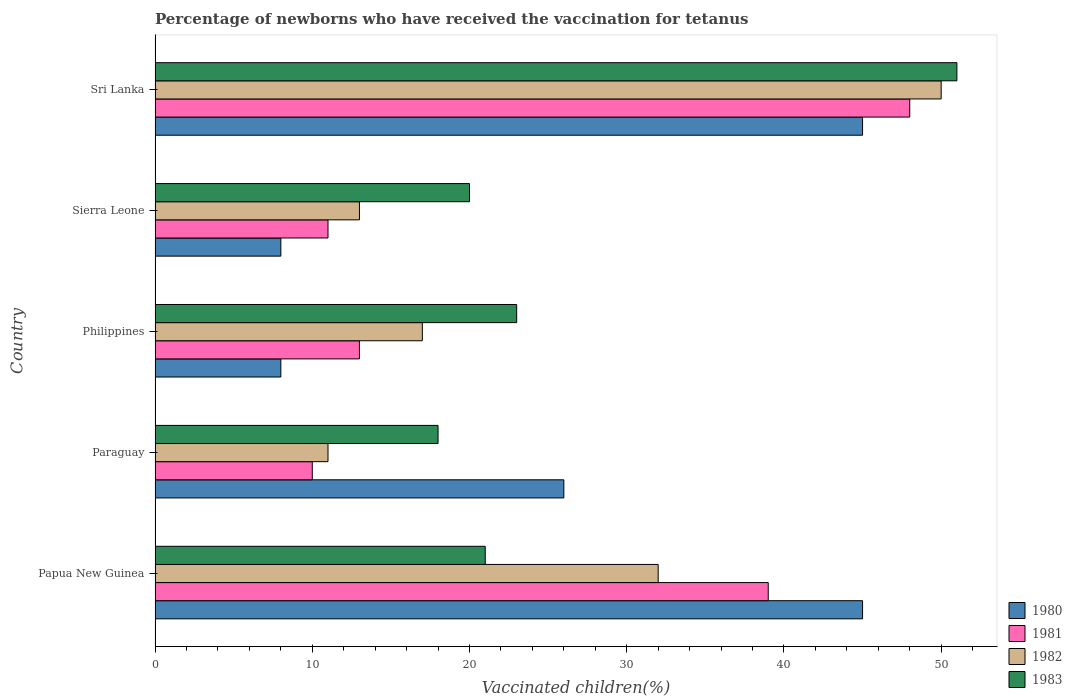Are the number of bars per tick equal to the number of legend labels?
Your answer should be compact. Yes. What is the label of the 4th group of bars from the top?
Provide a succinct answer. Paraguay. What is the percentage of vaccinated children in 1983 in Papua New Guinea?
Offer a terse response. 21. Across all countries, what is the maximum percentage of vaccinated children in 1981?
Offer a terse response. 48. Across all countries, what is the minimum percentage of vaccinated children in 1980?
Your answer should be compact. 8. In which country was the percentage of vaccinated children in 1981 maximum?
Offer a terse response. Sri Lanka. In which country was the percentage of vaccinated children in 1981 minimum?
Your answer should be compact. Paraguay. What is the total percentage of vaccinated children in 1981 in the graph?
Your answer should be very brief. 121. What is the difference between the percentage of vaccinated children in 1982 in Sierra Leone and that in Sri Lanka?
Make the answer very short. -37. What is the difference between the percentage of vaccinated children in 1981 in Papua New Guinea and the percentage of vaccinated children in 1980 in Sri Lanka?
Offer a very short reply. -6. What is the average percentage of vaccinated children in 1980 per country?
Offer a terse response. 26.4. What is the ratio of the percentage of vaccinated children in 1983 in Paraguay to that in Sri Lanka?
Your answer should be compact. 0.35. Is the difference between the percentage of vaccinated children in 1983 in Paraguay and Sri Lanka greater than the difference between the percentage of vaccinated children in 1980 in Paraguay and Sri Lanka?
Keep it short and to the point. No. In how many countries, is the percentage of vaccinated children in 1981 greater than the average percentage of vaccinated children in 1981 taken over all countries?
Your response must be concise. 2. Is the sum of the percentage of vaccinated children in 1980 in Philippines and Sri Lanka greater than the maximum percentage of vaccinated children in 1983 across all countries?
Keep it short and to the point. Yes. Is it the case that in every country, the sum of the percentage of vaccinated children in 1983 and percentage of vaccinated children in 1981 is greater than the percentage of vaccinated children in 1980?
Provide a succinct answer. Yes. How many bars are there?
Give a very brief answer. 20. What is the difference between two consecutive major ticks on the X-axis?
Your answer should be compact. 10. Are the values on the major ticks of X-axis written in scientific E-notation?
Provide a succinct answer. No. Does the graph contain any zero values?
Your answer should be compact. No. Does the graph contain grids?
Make the answer very short. No. How many legend labels are there?
Provide a succinct answer. 4. How are the legend labels stacked?
Provide a short and direct response. Vertical. What is the title of the graph?
Your response must be concise. Percentage of newborns who have received the vaccination for tetanus. What is the label or title of the X-axis?
Offer a terse response. Vaccinated children(%). What is the label or title of the Y-axis?
Offer a very short reply. Country. What is the Vaccinated children(%) of 1982 in Papua New Guinea?
Your answer should be very brief. 32. What is the Vaccinated children(%) in 1983 in Papua New Guinea?
Give a very brief answer. 21. What is the Vaccinated children(%) in 1980 in Paraguay?
Offer a terse response. 26. What is the Vaccinated children(%) in 1981 in Paraguay?
Give a very brief answer. 10. What is the Vaccinated children(%) in 1982 in Paraguay?
Offer a very short reply. 11. What is the Vaccinated children(%) in 1983 in Paraguay?
Your answer should be very brief. 18. What is the Vaccinated children(%) in 1980 in Philippines?
Make the answer very short. 8. What is the Vaccinated children(%) in 1981 in Philippines?
Ensure brevity in your answer.  13. What is the Vaccinated children(%) of 1980 in Sierra Leone?
Provide a succinct answer. 8. What is the Vaccinated children(%) in 1981 in Sierra Leone?
Your response must be concise. 11. What is the Vaccinated children(%) of 1982 in Sierra Leone?
Give a very brief answer. 13. Across all countries, what is the maximum Vaccinated children(%) in 1980?
Your response must be concise. 45. Across all countries, what is the maximum Vaccinated children(%) of 1981?
Offer a very short reply. 48. Across all countries, what is the maximum Vaccinated children(%) in 1982?
Give a very brief answer. 50. Across all countries, what is the maximum Vaccinated children(%) of 1983?
Offer a very short reply. 51. Across all countries, what is the minimum Vaccinated children(%) in 1980?
Your answer should be very brief. 8. What is the total Vaccinated children(%) of 1980 in the graph?
Provide a short and direct response. 132. What is the total Vaccinated children(%) of 1981 in the graph?
Provide a short and direct response. 121. What is the total Vaccinated children(%) of 1982 in the graph?
Ensure brevity in your answer.  123. What is the total Vaccinated children(%) in 1983 in the graph?
Provide a short and direct response. 133. What is the difference between the Vaccinated children(%) of 1981 in Papua New Guinea and that in Paraguay?
Keep it short and to the point. 29. What is the difference between the Vaccinated children(%) in 1982 in Papua New Guinea and that in Paraguay?
Offer a very short reply. 21. What is the difference between the Vaccinated children(%) in 1980 in Papua New Guinea and that in Philippines?
Your answer should be very brief. 37. What is the difference between the Vaccinated children(%) of 1981 in Papua New Guinea and that in Philippines?
Your answer should be very brief. 26. What is the difference between the Vaccinated children(%) in 1983 in Papua New Guinea and that in Philippines?
Keep it short and to the point. -2. What is the difference between the Vaccinated children(%) in 1981 in Papua New Guinea and that in Sierra Leone?
Give a very brief answer. 28. What is the difference between the Vaccinated children(%) of 1983 in Papua New Guinea and that in Sierra Leone?
Provide a short and direct response. 1. What is the difference between the Vaccinated children(%) of 1980 in Papua New Guinea and that in Sri Lanka?
Your response must be concise. 0. What is the difference between the Vaccinated children(%) in 1981 in Papua New Guinea and that in Sri Lanka?
Your answer should be compact. -9. What is the difference between the Vaccinated children(%) of 1982 in Papua New Guinea and that in Sri Lanka?
Your response must be concise. -18. What is the difference between the Vaccinated children(%) in 1983 in Papua New Guinea and that in Sri Lanka?
Offer a terse response. -30. What is the difference between the Vaccinated children(%) of 1981 in Paraguay and that in Philippines?
Give a very brief answer. -3. What is the difference between the Vaccinated children(%) in 1982 in Paraguay and that in Philippines?
Your answer should be very brief. -6. What is the difference between the Vaccinated children(%) in 1983 in Paraguay and that in Philippines?
Offer a terse response. -5. What is the difference between the Vaccinated children(%) in 1980 in Paraguay and that in Sierra Leone?
Give a very brief answer. 18. What is the difference between the Vaccinated children(%) in 1981 in Paraguay and that in Sierra Leone?
Offer a terse response. -1. What is the difference between the Vaccinated children(%) in 1982 in Paraguay and that in Sierra Leone?
Your response must be concise. -2. What is the difference between the Vaccinated children(%) in 1983 in Paraguay and that in Sierra Leone?
Ensure brevity in your answer.  -2. What is the difference between the Vaccinated children(%) of 1981 in Paraguay and that in Sri Lanka?
Provide a short and direct response. -38. What is the difference between the Vaccinated children(%) of 1982 in Paraguay and that in Sri Lanka?
Ensure brevity in your answer.  -39. What is the difference between the Vaccinated children(%) in 1983 in Paraguay and that in Sri Lanka?
Provide a succinct answer. -33. What is the difference between the Vaccinated children(%) in 1980 in Philippines and that in Sierra Leone?
Your response must be concise. 0. What is the difference between the Vaccinated children(%) in 1983 in Philippines and that in Sierra Leone?
Provide a succinct answer. 3. What is the difference between the Vaccinated children(%) in 1980 in Philippines and that in Sri Lanka?
Provide a short and direct response. -37. What is the difference between the Vaccinated children(%) of 1981 in Philippines and that in Sri Lanka?
Your answer should be compact. -35. What is the difference between the Vaccinated children(%) in 1982 in Philippines and that in Sri Lanka?
Make the answer very short. -33. What is the difference between the Vaccinated children(%) in 1980 in Sierra Leone and that in Sri Lanka?
Make the answer very short. -37. What is the difference between the Vaccinated children(%) in 1981 in Sierra Leone and that in Sri Lanka?
Provide a short and direct response. -37. What is the difference between the Vaccinated children(%) of 1982 in Sierra Leone and that in Sri Lanka?
Give a very brief answer. -37. What is the difference between the Vaccinated children(%) of 1983 in Sierra Leone and that in Sri Lanka?
Provide a short and direct response. -31. What is the difference between the Vaccinated children(%) of 1982 in Papua New Guinea and the Vaccinated children(%) of 1983 in Paraguay?
Your response must be concise. 14. What is the difference between the Vaccinated children(%) in 1980 in Papua New Guinea and the Vaccinated children(%) in 1981 in Philippines?
Ensure brevity in your answer.  32. What is the difference between the Vaccinated children(%) of 1980 in Papua New Guinea and the Vaccinated children(%) of 1982 in Philippines?
Your answer should be compact. 28. What is the difference between the Vaccinated children(%) in 1980 in Papua New Guinea and the Vaccinated children(%) in 1983 in Philippines?
Your answer should be very brief. 22. What is the difference between the Vaccinated children(%) of 1981 in Papua New Guinea and the Vaccinated children(%) of 1982 in Philippines?
Provide a succinct answer. 22. What is the difference between the Vaccinated children(%) of 1981 in Papua New Guinea and the Vaccinated children(%) of 1983 in Philippines?
Give a very brief answer. 16. What is the difference between the Vaccinated children(%) in 1980 in Papua New Guinea and the Vaccinated children(%) in 1981 in Sierra Leone?
Give a very brief answer. 34. What is the difference between the Vaccinated children(%) in 1980 in Papua New Guinea and the Vaccinated children(%) in 1981 in Sri Lanka?
Your answer should be very brief. -3. What is the difference between the Vaccinated children(%) in 1980 in Papua New Guinea and the Vaccinated children(%) in 1983 in Sri Lanka?
Keep it short and to the point. -6. What is the difference between the Vaccinated children(%) of 1980 in Paraguay and the Vaccinated children(%) of 1981 in Philippines?
Offer a terse response. 13. What is the difference between the Vaccinated children(%) of 1980 in Paraguay and the Vaccinated children(%) of 1983 in Philippines?
Offer a terse response. 3. What is the difference between the Vaccinated children(%) of 1981 in Paraguay and the Vaccinated children(%) of 1982 in Philippines?
Provide a short and direct response. -7. What is the difference between the Vaccinated children(%) in 1980 in Paraguay and the Vaccinated children(%) in 1982 in Sierra Leone?
Your answer should be compact. 13. What is the difference between the Vaccinated children(%) of 1980 in Paraguay and the Vaccinated children(%) of 1983 in Sierra Leone?
Offer a terse response. 6. What is the difference between the Vaccinated children(%) in 1981 in Paraguay and the Vaccinated children(%) in 1982 in Sierra Leone?
Make the answer very short. -3. What is the difference between the Vaccinated children(%) of 1982 in Paraguay and the Vaccinated children(%) of 1983 in Sierra Leone?
Your answer should be very brief. -9. What is the difference between the Vaccinated children(%) in 1980 in Paraguay and the Vaccinated children(%) in 1981 in Sri Lanka?
Make the answer very short. -22. What is the difference between the Vaccinated children(%) of 1981 in Paraguay and the Vaccinated children(%) of 1983 in Sri Lanka?
Offer a terse response. -41. What is the difference between the Vaccinated children(%) in 1982 in Paraguay and the Vaccinated children(%) in 1983 in Sri Lanka?
Provide a succinct answer. -40. What is the difference between the Vaccinated children(%) in 1980 in Philippines and the Vaccinated children(%) in 1982 in Sierra Leone?
Your answer should be compact. -5. What is the difference between the Vaccinated children(%) in 1980 in Philippines and the Vaccinated children(%) in 1983 in Sierra Leone?
Provide a succinct answer. -12. What is the difference between the Vaccinated children(%) in 1981 in Philippines and the Vaccinated children(%) in 1982 in Sierra Leone?
Your answer should be very brief. 0. What is the difference between the Vaccinated children(%) of 1982 in Philippines and the Vaccinated children(%) of 1983 in Sierra Leone?
Offer a very short reply. -3. What is the difference between the Vaccinated children(%) in 1980 in Philippines and the Vaccinated children(%) in 1982 in Sri Lanka?
Provide a succinct answer. -42. What is the difference between the Vaccinated children(%) in 1980 in Philippines and the Vaccinated children(%) in 1983 in Sri Lanka?
Your answer should be compact. -43. What is the difference between the Vaccinated children(%) in 1981 in Philippines and the Vaccinated children(%) in 1982 in Sri Lanka?
Ensure brevity in your answer.  -37. What is the difference between the Vaccinated children(%) in 1981 in Philippines and the Vaccinated children(%) in 1983 in Sri Lanka?
Your response must be concise. -38. What is the difference between the Vaccinated children(%) in 1982 in Philippines and the Vaccinated children(%) in 1983 in Sri Lanka?
Your response must be concise. -34. What is the difference between the Vaccinated children(%) of 1980 in Sierra Leone and the Vaccinated children(%) of 1981 in Sri Lanka?
Ensure brevity in your answer.  -40. What is the difference between the Vaccinated children(%) in 1980 in Sierra Leone and the Vaccinated children(%) in 1982 in Sri Lanka?
Make the answer very short. -42. What is the difference between the Vaccinated children(%) in 1980 in Sierra Leone and the Vaccinated children(%) in 1983 in Sri Lanka?
Provide a succinct answer. -43. What is the difference between the Vaccinated children(%) of 1981 in Sierra Leone and the Vaccinated children(%) of 1982 in Sri Lanka?
Your answer should be very brief. -39. What is the difference between the Vaccinated children(%) in 1981 in Sierra Leone and the Vaccinated children(%) in 1983 in Sri Lanka?
Give a very brief answer. -40. What is the difference between the Vaccinated children(%) in 1982 in Sierra Leone and the Vaccinated children(%) in 1983 in Sri Lanka?
Your response must be concise. -38. What is the average Vaccinated children(%) of 1980 per country?
Offer a very short reply. 26.4. What is the average Vaccinated children(%) of 1981 per country?
Your response must be concise. 24.2. What is the average Vaccinated children(%) of 1982 per country?
Ensure brevity in your answer.  24.6. What is the average Vaccinated children(%) in 1983 per country?
Your answer should be compact. 26.6. What is the difference between the Vaccinated children(%) of 1980 and Vaccinated children(%) of 1981 in Papua New Guinea?
Ensure brevity in your answer.  6. What is the difference between the Vaccinated children(%) in 1980 and Vaccinated children(%) in 1983 in Papua New Guinea?
Provide a short and direct response. 24. What is the difference between the Vaccinated children(%) in 1981 and Vaccinated children(%) in 1983 in Papua New Guinea?
Make the answer very short. 18. What is the difference between the Vaccinated children(%) of 1980 and Vaccinated children(%) of 1981 in Paraguay?
Your response must be concise. 16. What is the difference between the Vaccinated children(%) of 1980 and Vaccinated children(%) of 1982 in Paraguay?
Make the answer very short. 15. What is the difference between the Vaccinated children(%) of 1981 and Vaccinated children(%) of 1982 in Paraguay?
Offer a terse response. -1. What is the difference between the Vaccinated children(%) in 1981 and Vaccinated children(%) in 1983 in Paraguay?
Your answer should be very brief. -8. What is the difference between the Vaccinated children(%) in 1982 and Vaccinated children(%) in 1983 in Paraguay?
Provide a succinct answer. -7. What is the difference between the Vaccinated children(%) in 1980 and Vaccinated children(%) in 1983 in Philippines?
Ensure brevity in your answer.  -15. What is the difference between the Vaccinated children(%) of 1982 and Vaccinated children(%) of 1983 in Philippines?
Your answer should be compact. -6. What is the difference between the Vaccinated children(%) of 1980 and Vaccinated children(%) of 1981 in Sierra Leone?
Offer a very short reply. -3. What is the difference between the Vaccinated children(%) of 1980 and Vaccinated children(%) of 1983 in Sierra Leone?
Ensure brevity in your answer.  -12. What is the difference between the Vaccinated children(%) in 1982 and Vaccinated children(%) in 1983 in Sierra Leone?
Offer a terse response. -7. What is the difference between the Vaccinated children(%) of 1980 and Vaccinated children(%) of 1981 in Sri Lanka?
Your answer should be very brief. -3. What is the difference between the Vaccinated children(%) of 1981 and Vaccinated children(%) of 1982 in Sri Lanka?
Your response must be concise. -2. What is the difference between the Vaccinated children(%) in 1981 and Vaccinated children(%) in 1983 in Sri Lanka?
Make the answer very short. -3. What is the difference between the Vaccinated children(%) of 1982 and Vaccinated children(%) of 1983 in Sri Lanka?
Offer a very short reply. -1. What is the ratio of the Vaccinated children(%) in 1980 in Papua New Guinea to that in Paraguay?
Your answer should be very brief. 1.73. What is the ratio of the Vaccinated children(%) of 1981 in Papua New Guinea to that in Paraguay?
Your answer should be compact. 3.9. What is the ratio of the Vaccinated children(%) in 1982 in Papua New Guinea to that in Paraguay?
Provide a succinct answer. 2.91. What is the ratio of the Vaccinated children(%) of 1983 in Papua New Guinea to that in Paraguay?
Provide a succinct answer. 1.17. What is the ratio of the Vaccinated children(%) of 1980 in Papua New Guinea to that in Philippines?
Provide a short and direct response. 5.62. What is the ratio of the Vaccinated children(%) in 1981 in Papua New Guinea to that in Philippines?
Your answer should be very brief. 3. What is the ratio of the Vaccinated children(%) of 1982 in Papua New Guinea to that in Philippines?
Offer a terse response. 1.88. What is the ratio of the Vaccinated children(%) of 1983 in Papua New Guinea to that in Philippines?
Your answer should be very brief. 0.91. What is the ratio of the Vaccinated children(%) in 1980 in Papua New Guinea to that in Sierra Leone?
Make the answer very short. 5.62. What is the ratio of the Vaccinated children(%) of 1981 in Papua New Guinea to that in Sierra Leone?
Give a very brief answer. 3.55. What is the ratio of the Vaccinated children(%) in 1982 in Papua New Guinea to that in Sierra Leone?
Your answer should be very brief. 2.46. What is the ratio of the Vaccinated children(%) in 1980 in Papua New Guinea to that in Sri Lanka?
Give a very brief answer. 1. What is the ratio of the Vaccinated children(%) of 1981 in Papua New Guinea to that in Sri Lanka?
Provide a short and direct response. 0.81. What is the ratio of the Vaccinated children(%) in 1982 in Papua New Guinea to that in Sri Lanka?
Keep it short and to the point. 0.64. What is the ratio of the Vaccinated children(%) in 1983 in Papua New Guinea to that in Sri Lanka?
Provide a short and direct response. 0.41. What is the ratio of the Vaccinated children(%) in 1980 in Paraguay to that in Philippines?
Your response must be concise. 3.25. What is the ratio of the Vaccinated children(%) in 1981 in Paraguay to that in Philippines?
Your answer should be compact. 0.77. What is the ratio of the Vaccinated children(%) of 1982 in Paraguay to that in Philippines?
Your answer should be very brief. 0.65. What is the ratio of the Vaccinated children(%) in 1983 in Paraguay to that in Philippines?
Give a very brief answer. 0.78. What is the ratio of the Vaccinated children(%) of 1980 in Paraguay to that in Sierra Leone?
Offer a very short reply. 3.25. What is the ratio of the Vaccinated children(%) of 1981 in Paraguay to that in Sierra Leone?
Your answer should be compact. 0.91. What is the ratio of the Vaccinated children(%) of 1982 in Paraguay to that in Sierra Leone?
Offer a very short reply. 0.85. What is the ratio of the Vaccinated children(%) of 1983 in Paraguay to that in Sierra Leone?
Give a very brief answer. 0.9. What is the ratio of the Vaccinated children(%) of 1980 in Paraguay to that in Sri Lanka?
Your answer should be very brief. 0.58. What is the ratio of the Vaccinated children(%) in 1981 in Paraguay to that in Sri Lanka?
Give a very brief answer. 0.21. What is the ratio of the Vaccinated children(%) of 1982 in Paraguay to that in Sri Lanka?
Your response must be concise. 0.22. What is the ratio of the Vaccinated children(%) of 1983 in Paraguay to that in Sri Lanka?
Provide a short and direct response. 0.35. What is the ratio of the Vaccinated children(%) in 1981 in Philippines to that in Sierra Leone?
Your answer should be compact. 1.18. What is the ratio of the Vaccinated children(%) in 1982 in Philippines to that in Sierra Leone?
Provide a succinct answer. 1.31. What is the ratio of the Vaccinated children(%) in 1983 in Philippines to that in Sierra Leone?
Your response must be concise. 1.15. What is the ratio of the Vaccinated children(%) in 1980 in Philippines to that in Sri Lanka?
Offer a terse response. 0.18. What is the ratio of the Vaccinated children(%) in 1981 in Philippines to that in Sri Lanka?
Provide a succinct answer. 0.27. What is the ratio of the Vaccinated children(%) of 1982 in Philippines to that in Sri Lanka?
Offer a terse response. 0.34. What is the ratio of the Vaccinated children(%) of 1983 in Philippines to that in Sri Lanka?
Your answer should be compact. 0.45. What is the ratio of the Vaccinated children(%) of 1980 in Sierra Leone to that in Sri Lanka?
Provide a short and direct response. 0.18. What is the ratio of the Vaccinated children(%) of 1981 in Sierra Leone to that in Sri Lanka?
Your answer should be very brief. 0.23. What is the ratio of the Vaccinated children(%) in 1982 in Sierra Leone to that in Sri Lanka?
Offer a very short reply. 0.26. What is the ratio of the Vaccinated children(%) of 1983 in Sierra Leone to that in Sri Lanka?
Your response must be concise. 0.39. What is the difference between the highest and the second highest Vaccinated children(%) of 1980?
Offer a terse response. 0. What is the difference between the highest and the second highest Vaccinated children(%) in 1981?
Your response must be concise. 9. What is the difference between the highest and the lowest Vaccinated children(%) in 1980?
Ensure brevity in your answer.  37. What is the difference between the highest and the lowest Vaccinated children(%) of 1981?
Make the answer very short. 38. 